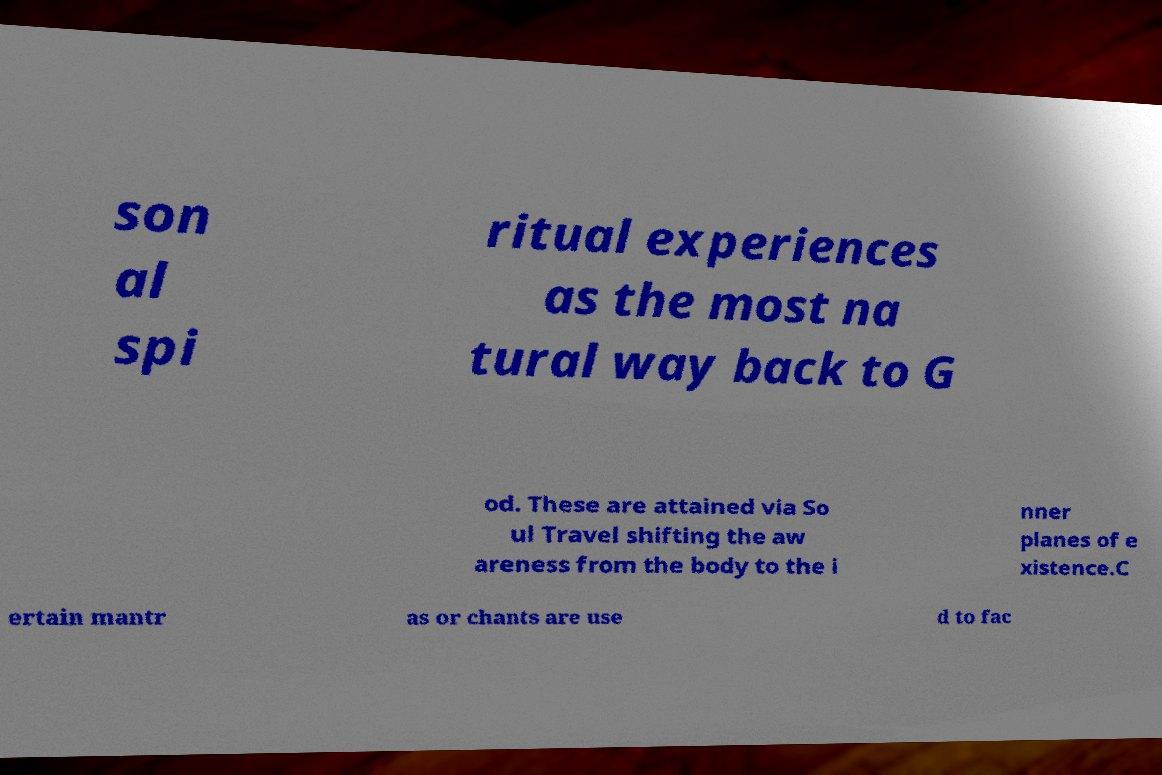For documentation purposes, I need the text within this image transcribed. Could you provide that? son al spi ritual experiences as the most na tural way back to G od. These are attained via So ul Travel shifting the aw areness from the body to the i nner planes of e xistence.C ertain mantr as or chants are use d to fac 